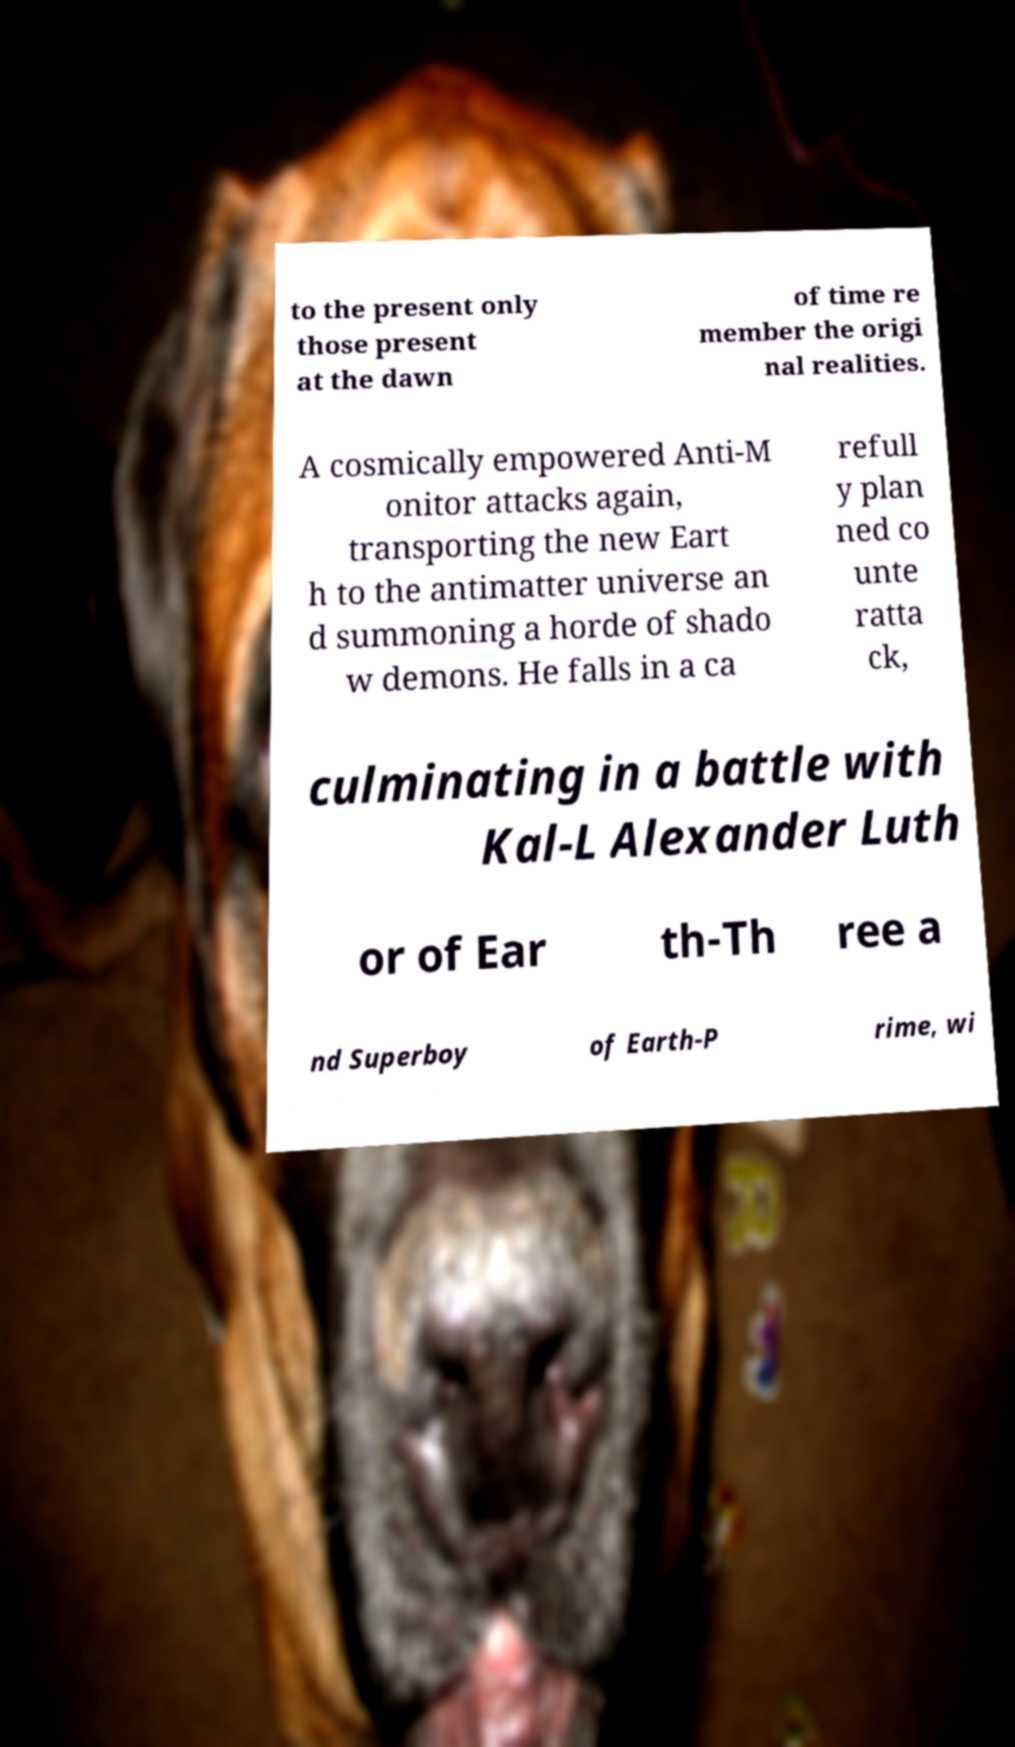I need the written content from this picture converted into text. Can you do that? to the present only those present at the dawn of time re member the origi nal realities. A cosmically empowered Anti-M onitor attacks again, transporting the new Eart h to the antimatter universe an d summoning a horde of shado w demons. He falls in a ca refull y plan ned co unte ratta ck, culminating in a battle with Kal-L Alexander Luth or of Ear th-Th ree a nd Superboy of Earth-P rime, wi 